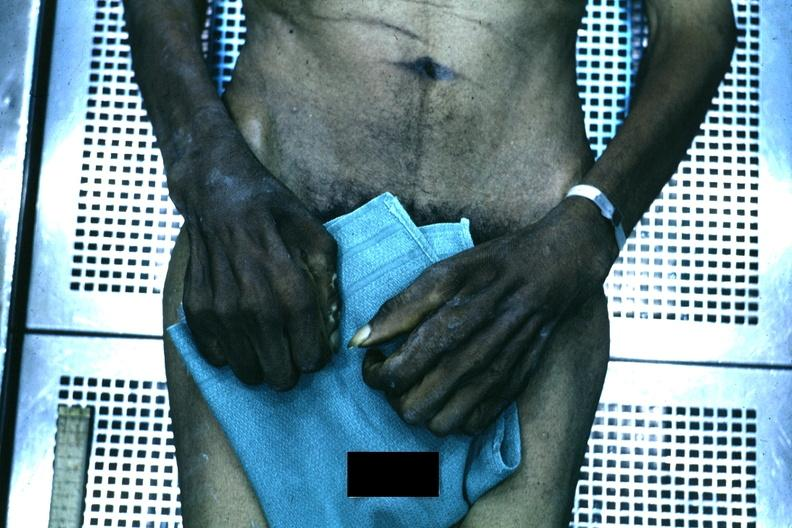what are present?
Answer the question using a single word or phrase. Extremities 